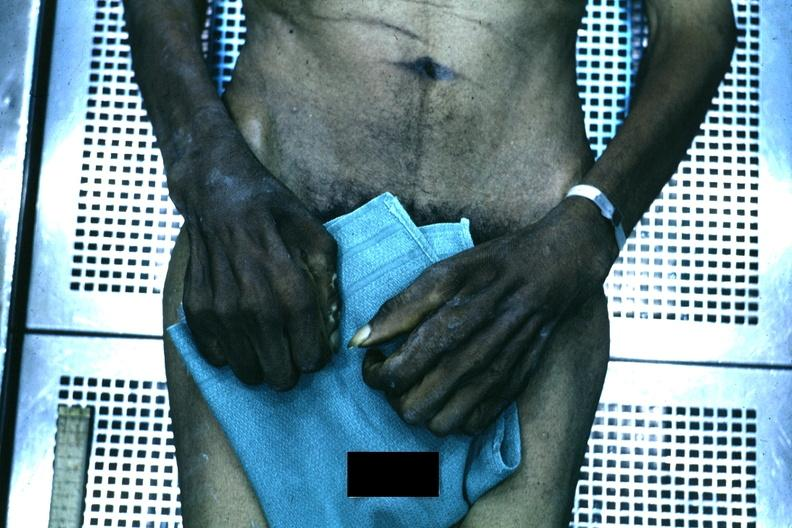what are present?
Answer the question using a single word or phrase. Extremities 